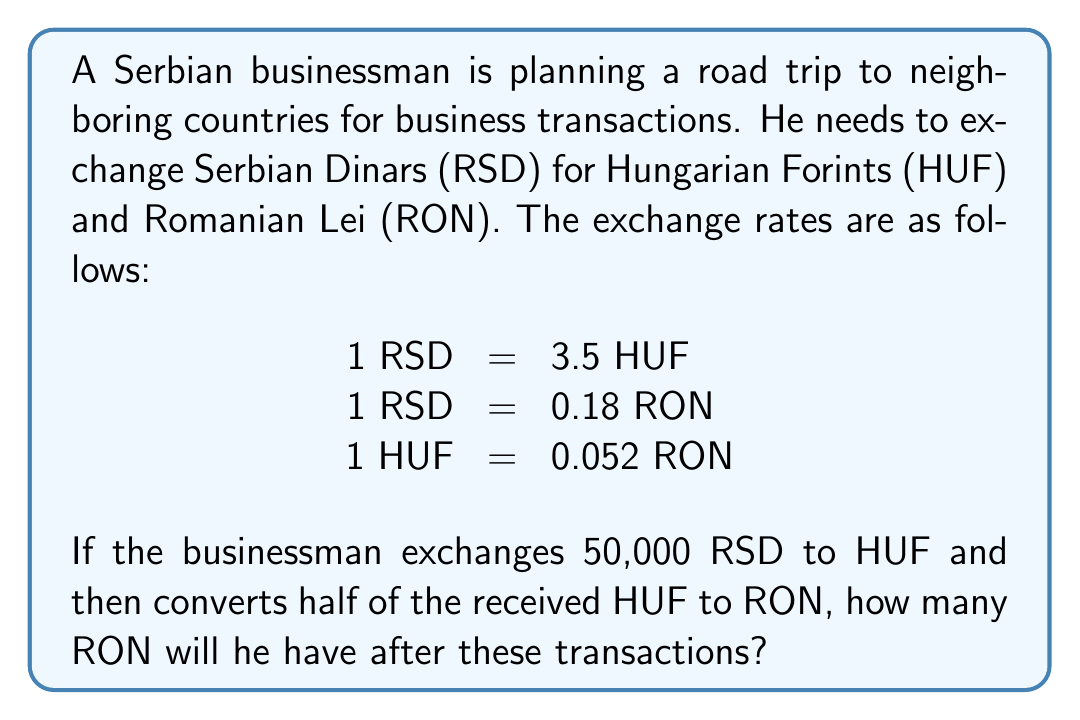Provide a solution to this math problem. Let's solve this problem step by step:

1. Convert RSD to HUF:
   $$50,000 \text{ RSD} \times 3.5 \frac{\text{HUF}}{\text{RSD}} = 175,000 \text{ HUF}$$

2. Calculate half of the HUF amount:
   $$175,000 \text{ HUF} \div 2 = 87,500 \text{ HUF}$$

3. Convert 87,500 HUF to RON:
   $$87,500 \text{ HUF} \times 0.052 \frac{\text{RON}}{\text{HUF}} = 4,550 \text{ RON}$$

4. Calculate the remaining RSD amount after the first conversion:
   $$50,000 \text{ RSD} \div 2 = 25,000 \text{ RSD}$$

5. Convert the remaining 25,000 RSD directly to RON:
   $$25,000 \text{ RSD} \times 0.18 \frac{\text{RON}}{\text{RSD}} = 4,500 \text{ RON}$$

6. Sum up the total RON:
   $$4,550 \text{ RON} + 4,500 \text{ RON} = 9,050 \text{ RON}$$

Therefore, after these transactions, the businessman will have 9,050 RON.
Answer: 9,050 RON 